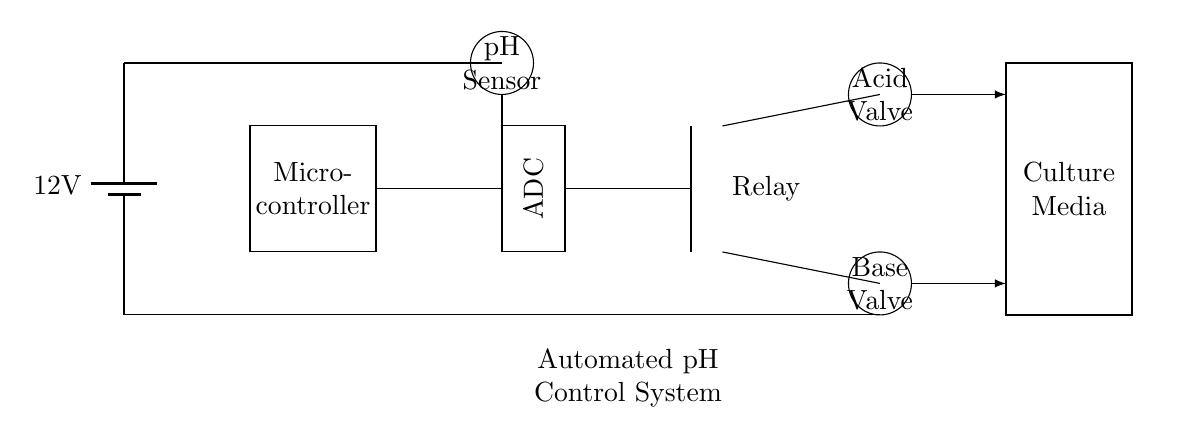What is the voltage of this circuit? The voltage is 12 volts, which is indicated by the battery at the beginning of the circuit diagram.
Answer: 12 volts What is the function of the microcontroller in this circuit? The microcontroller processes the data from the pH sensor and controls the relay to operate the solenoid valves based on the pH levels detected.
Answer: Control How many solenoid valves are present in the circuit? There are two solenoid valves, one for acid and one for base, as represented by the two circles labeled in the diagram.
Answer: Two What type of sensor is used in this automated control system? The circuit includes a pH sensor, which is responsible for measuring the acidity or alkalinity of the culture media.
Answer: pH sensor What is the role of the ADC in this circuit? The Analog-to-Digital Converter (ADC) converts the analog pH signal from the sensor into a digital signal that can be processed by the microcontroller.
Answer: Conversion How is the pH adjustment achieved in this circuit? pH adjustment is achieved by controlling the solenoid valves to release acid or base into the culture media based on the pH measurements.
Answer: Solenoid valves What does the relay control in this automated pH control system? The relay controls the opening and closing of the solenoid valves, allowing and stopping the flow of acid and base to adjust the pH level.
Answer: Solenoid valves 